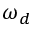<formula> <loc_0><loc_0><loc_500><loc_500>\omega _ { d }</formula> 